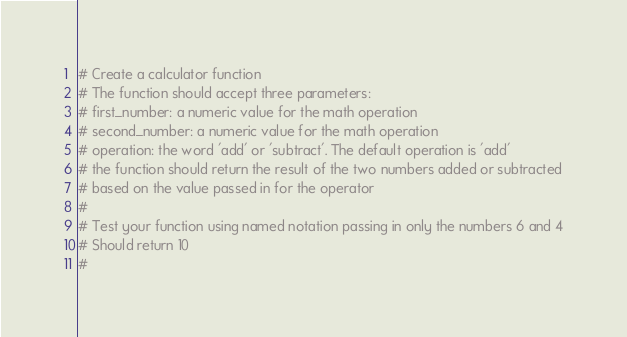<code> <loc_0><loc_0><loc_500><loc_500><_Python_># Create a calculator function
# The function should accept three parameters:
# first_number: a numeric value for the math operation
# second_number: a numeric value for the math operation
# operation: the word 'add' or 'subtract'. The default operation is 'add'
# the function should return the result of the two numbers added or subtracted
# based on the value passed in for the operator
#
# Test your function using named notation passing in only the numbers 6 and 4
# Should return 10
#</code> 